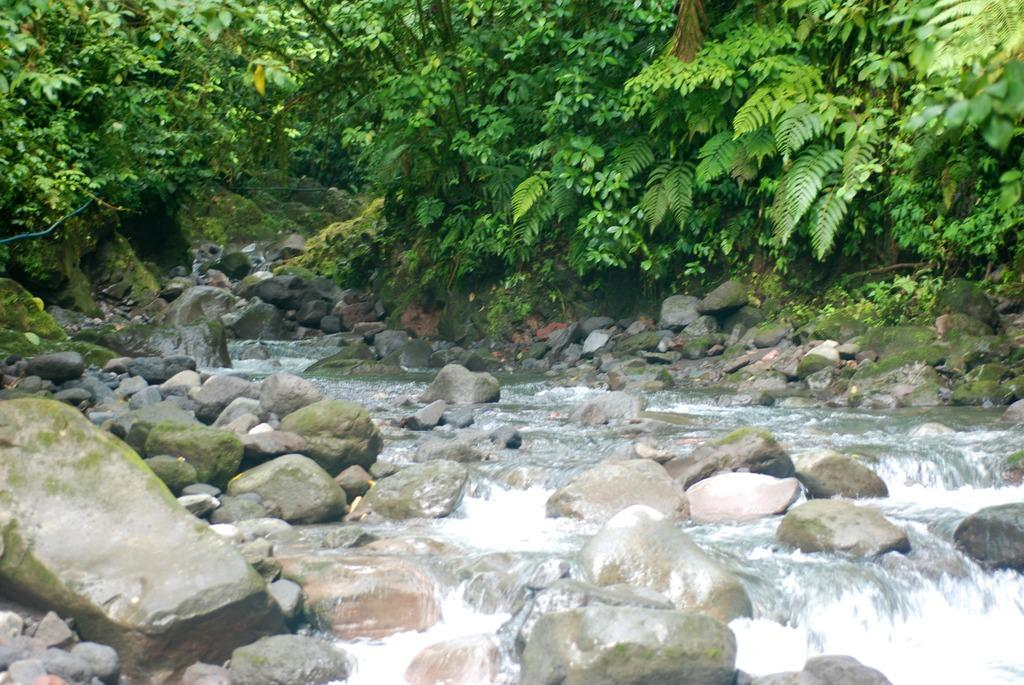What type of vegetation can be seen in the image? There are many trees, plants, bushes, and grass in the image. What is the ground made of in the image? There are stones in the image, and water is flowing over rocks. Can you describe the water in the image? Water is flowing over rocks in the image. What type of quartz can be seen in the image? There is no quartz present in the image. How does the uncle in the image contribute to the journey? There is no uncle or journey depicted in the image. 